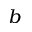Convert formula to latex. <formula><loc_0><loc_0><loc_500><loc_500>^ { b }</formula> 